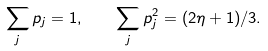<formula> <loc_0><loc_0><loc_500><loc_500>\sum _ { j } p _ { j } = 1 , \quad \sum _ { j } p _ { j } ^ { 2 } = ( 2 \eta + 1 ) / 3 .</formula> 